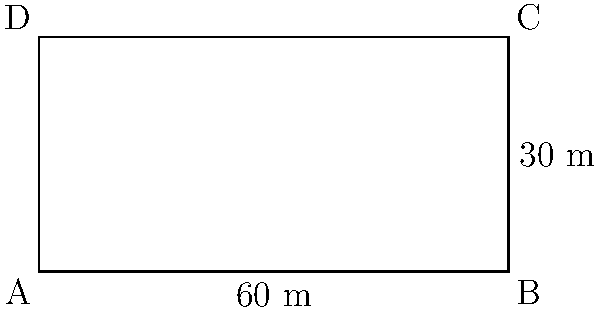You have a rectangular blueberry field with a length of $60$ meters and a width of $30$ meters. You want to install an organic pest-repelling fence around the entire field. How many meters of fencing material will you need to completely enclose the field? To solve this problem, we need to calculate the perimeter of the rectangular field. The perimeter is the distance around the entire shape.

Step 1: Identify the formula for the perimeter of a rectangle.
Perimeter of a rectangle = 2 × (length + width)

Step 2: Substitute the given values into the formula.
Length = $60$ m
Width = $30$ m

Perimeter = 2 × ($60$ m + $30$ m)

Step 3: Calculate the sum inside the parentheses.
Perimeter = 2 × $90$ m

Step 4: Multiply to get the final result.
Perimeter = $180$ m

Therefore, you will need 180 meters of fencing material to completely enclose the blueberry field.
Answer: $180$ m 